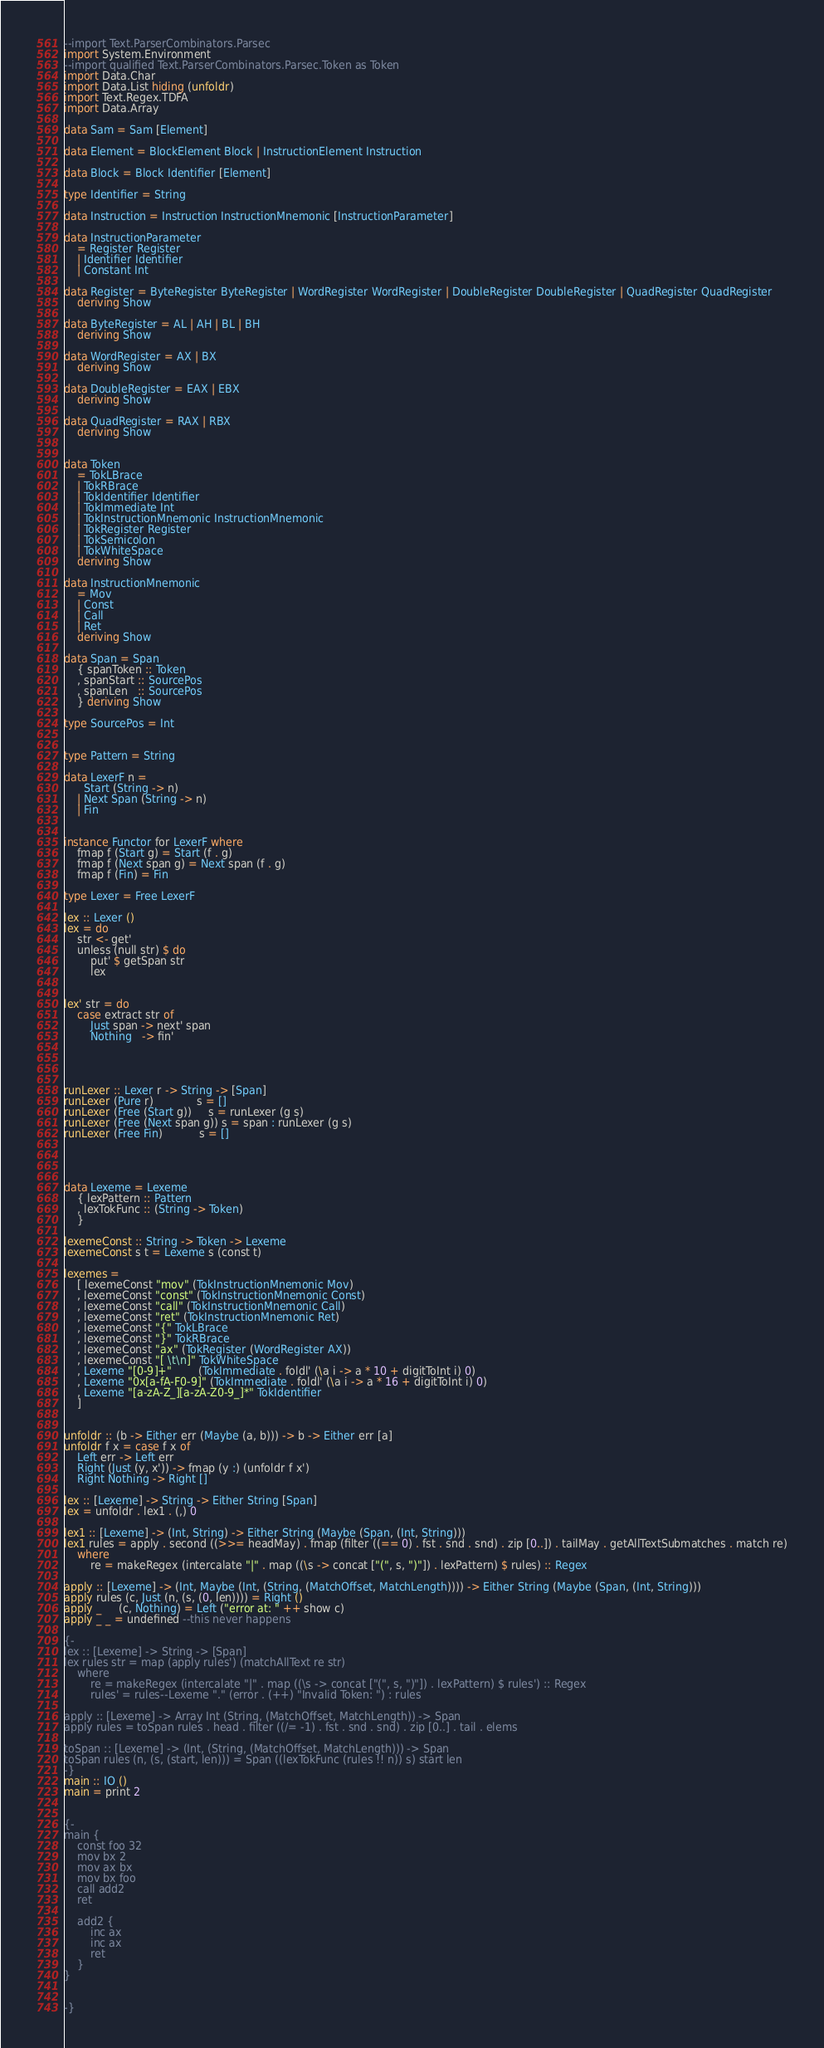<code> <loc_0><loc_0><loc_500><loc_500><_Haskell_>--import Text.ParserCombinators.Parsec
import System.Environment
--import qualified Text.ParserCombinators.Parsec.Token as Token
import Data.Char
import Data.List hiding (unfoldr)
import Text.Regex.TDFA
import Data.Array

data Sam = Sam [Element]

data Element = BlockElement Block | InstructionElement Instruction

data Block = Block Identifier [Element]

type Identifier = String

data Instruction = Instruction InstructionMnemonic [InstructionParameter]

data InstructionParameter
    = Register Register
    | Identifier Identifier
    | Constant Int

data Register = ByteRegister ByteRegister | WordRegister WordRegister | DoubleRegister DoubleRegister | QuadRegister QuadRegister
    deriving Show

data ByteRegister = AL | AH | BL | BH
    deriving Show

data WordRegister = AX | BX
    deriving Show

data DoubleRegister = EAX | EBX
    deriving Show

data QuadRegister = RAX | RBX
    deriving Show


data Token
    = TokLBrace
    | TokRBrace
    | TokIdentifier Identifier
    | TokImmediate Int
    | TokInstructionMnemonic InstructionMnemonic
    | TokRegister Register
    | TokSemicolon
    | TokWhiteSpace
    deriving Show

data InstructionMnemonic
    = Mov
    | Const
    | Call
    | Ret
    deriving Show

data Span = Span
    { spanToken :: Token
    , spanStart :: SourcePos
    , spanLen   :: SourcePos
    } deriving Show

type SourcePos = Int


type Pattern = String

data LexerF n =
      Start (String -> n)
    | Next Span (String -> n)
    | Fin


instance Functor for LexerF where
    fmap f (Start g) = Start (f . g)
    fmap f (Next span g) = Next span (f . g)
    fmap f (Fin) = Fin

type Lexer = Free LexerF

lex :: Lexer ()
lex = do
    str <- get'
    unless (null str) $ do
        put' $ getSpan str
        lex


lex' str = do
    case extract str of
        Just span -> next' span
        Nothing   -> fin'




runLexer :: Lexer r -> String -> [Span]
runLexer (Pure r)             s = []
runLexer (Free (Start g))     s = runLexer (g s)
runLexer (Free (Next span g)) s = span : runLexer (g s)
runLexer (Free Fin)           s = []




data Lexeme = Lexeme
    { lexPattern :: Pattern
    , lexTokFunc :: (String -> Token)
    }

lexemeConst :: String -> Token -> Lexeme
lexemeConst s t = Lexeme s (const t)

lexemes =
    [ lexemeConst "mov" (TokInstructionMnemonic Mov)
    , lexemeConst "const" (TokInstructionMnemonic Const)
    , lexemeConst "call" (TokInstructionMnemonic Call)
    , lexemeConst "ret" (TokInstructionMnemonic Ret)
    , lexemeConst "{" TokLBrace
    , lexemeConst "}" TokRBrace
    , lexemeConst "ax" (TokRegister (WordRegister AX))
    , lexemeConst "[ \t\n]" TokWhiteSpace
    , Lexeme "[0-9]+"        (TokImmediate . foldl' (\a i -> a * 10 + digitToInt i) 0)
    , Lexeme "0x[a-fA-F0-9]" (TokImmediate . foldl' (\a i -> a * 16 + digitToInt i) 0)
    , Lexeme "[a-zA-Z_][a-zA-Z0-9_]*" TokIdentifier
    ]


unfoldr :: (b -> Either err (Maybe (a, b))) -> b -> Either err [a]
unfoldr f x = case f x of
    Left err -> Left err
    Right (Just (y, x')) -> fmap (y :) (unfoldr f x')
    Right Nothing -> Right []

lex :: [Lexeme] -> String -> Either String [Span]
lex = unfoldr . lex1 . (,) 0

lex1 :: [Lexeme] -> (Int, String) -> Either String (Maybe (Span, (Int, String)))
lex1 rules = apply . second ((>>= headMay) . fmap (filter ((== 0) . fst . snd . snd) . zip [0..]) . tailMay . getAllTextSubmatches . match re)
    where
        re = makeRegex (intercalate "|" . map ((\s -> concat ["(", s, ")"]) . lexPattern) $ rules) :: Regex

apply :: [Lexeme] -> (Int, Maybe (Int, (String, (MatchOffset, MatchLength)))) -> Either String (Maybe (Span, (Int, String)))
apply rules (c, Just (n, (s, (0, len)))) = Right ()
apply _     (c, Nothing) = Left ("error at: " ++ show c)
apply _ _ = undefined --this never happens

{-
lex :: [Lexeme] -> String -> [Span]
lex rules str = map (apply rules') (matchAllText re str)
    where
        re = makeRegex (intercalate "|" . map ((\s -> concat ["(", s, ")"]) . lexPattern) $ rules') :: Regex
        rules' = rules--Lexeme "." (error . (++) "Invalid Token: ") : rules

apply :: [Lexeme] -> Array Int (String, (MatchOffset, MatchLength)) -> Span
apply rules = toSpan rules . head . filter ((/= -1) . fst . snd . snd) . zip [0..] . tail . elems

toSpan :: [Lexeme] -> (Int, (String, (MatchOffset, MatchLength))) -> Span
toSpan rules (n, (s, (start, len))) = Span ((lexTokFunc (rules !! n)) s) start len
-}
main :: IO ()
main = print 2


{-
main {
    const foo 32
    mov bx 2
    mov ax bx
    mov bx foo
    call add2
    ret

    add2 {
        inc ax
        inc ax
        ret
    }
}


-}
</code> 